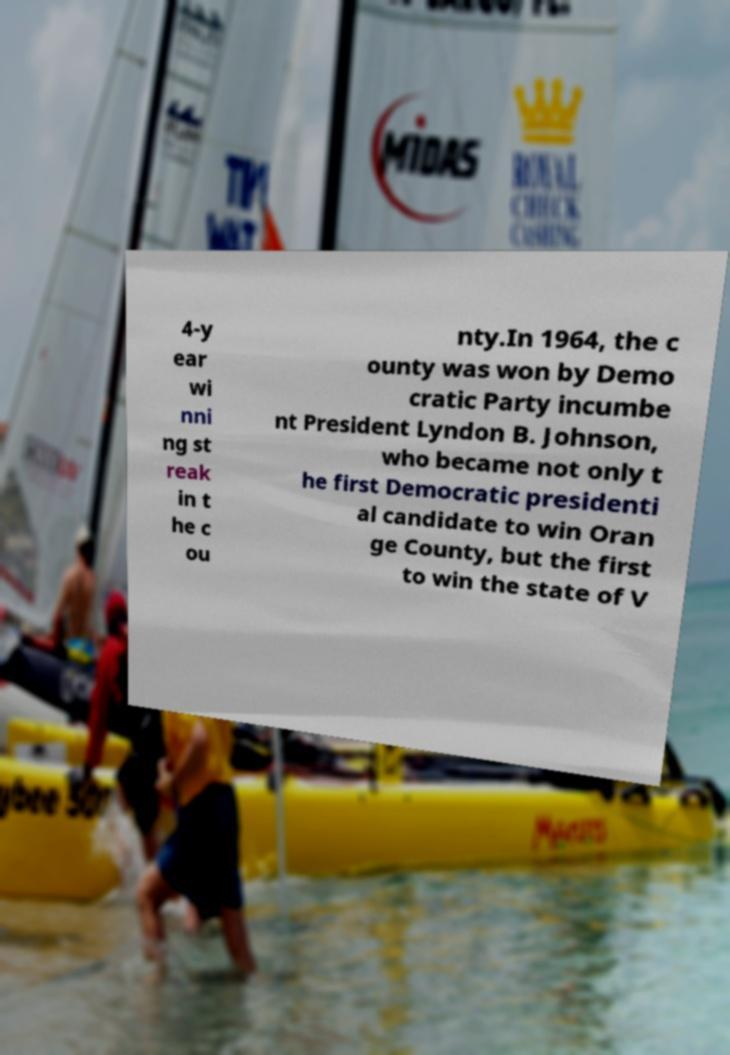Can you accurately transcribe the text from the provided image for me? 4-y ear wi nni ng st reak in t he c ou nty.In 1964, the c ounty was won by Demo cratic Party incumbe nt President Lyndon B. Johnson, who became not only t he first Democratic presidenti al candidate to win Oran ge County, but the first to win the state of V 